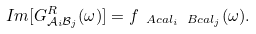<formula> <loc_0><loc_0><loc_500><loc_500>I m [ G ^ { R } _ { \mathcal { A } _ { i } \mathcal { B } _ { j } } ( \omega ) ] = f _ { \ A c a l _ { i } \ B c a l _ { j } } ( \omega ) .</formula> 